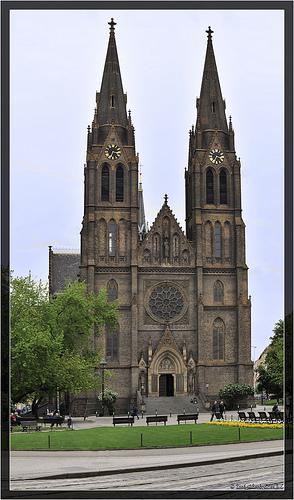Question: when do people come here?
Choices:
A. On Monday.
B. On Sunday.
C. On Saturday.
D. Every day.
Answer with the letter. Answer: B Question: how are the crosses displayed?
Choices:
A. On the front door.
B. On the spires.
C. On the side door.
D. On the front lawn.
Answer with the letter. Answer: B Question: what are people sitting on?
Choices:
A. The ground.
B. The benches.
C. The floor.
D. The sofas.
Answer with the letter. Answer: B 